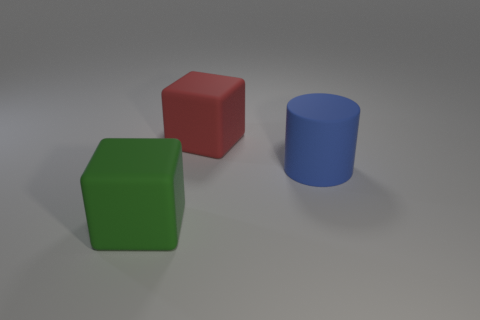Add 3 tiny purple metal cylinders. How many objects exist? 6 Subtract all cubes. How many objects are left? 1 Subtract 0 purple cubes. How many objects are left? 3 Subtract all big gray rubber cylinders. Subtract all big rubber blocks. How many objects are left? 1 Add 2 green objects. How many green objects are left? 3 Add 3 large cyan metal things. How many large cyan metal things exist? 3 